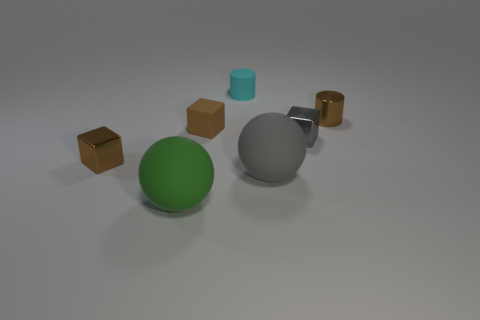What is the size of the brown metal thing that is to the right of the large object behind the large sphere that is on the left side of the big gray thing?
Your answer should be compact. Small. How many rubber things are either large gray balls or green things?
Provide a succinct answer. 2. Is the shape of the green thing the same as the large object that is to the right of the cyan rubber thing?
Offer a very short reply. Yes. Is the number of tiny cyan rubber cylinders behind the large green ball greater than the number of small cyan things on the left side of the tiny cyan matte cylinder?
Your answer should be compact. Yes. Is there any other thing of the same color as the rubber cube?
Your response must be concise. Yes. Are there any gray rubber objects in front of the large green sphere to the left of the shiny block that is on the right side of the green rubber sphere?
Your answer should be very brief. No. Is the shape of the brown metal object in front of the small metal cylinder the same as  the tiny brown rubber thing?
Ensure brevity in your answer.  Yes. Are there fewer metallic things that are behind the brown metal cylinder than matte objects in front of the cyan matte object?
Keep it short and to the point. Yes. What is the material of the cyan thing?
Your answer should be very brief. Rubber. Does the tiny matte cube have the same color as the object behind the tiny brown metal cylinder?
Provide a short and direct response. No. 